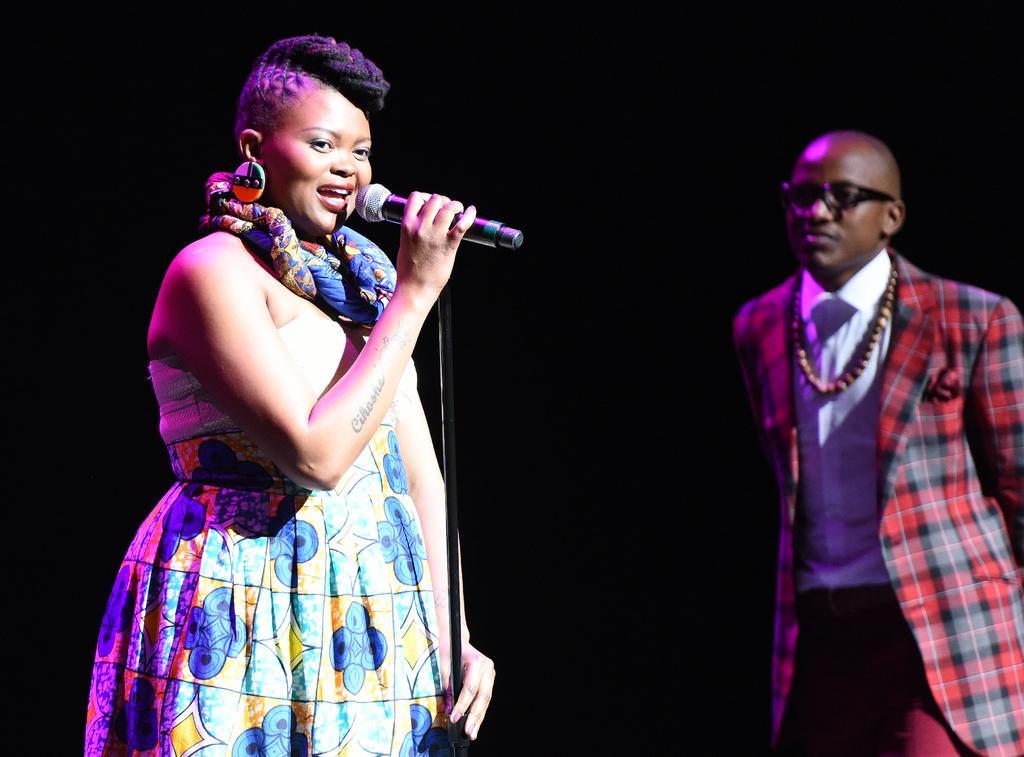Please provide a concise description of this image. In this image we can see a man and a woman standing. In that a woman is holding a mic with a stand. 